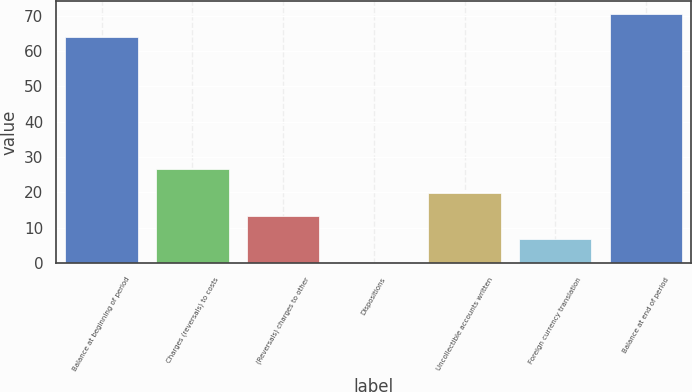Convert chart to OTSL. <chart><loc_0><loc_0><loc_500><loc_500><bar_chart><fcel>Balance at beginning of period<fcel>Charges (reversals) to costs<fcel>(Reversals) charges to other<fcel>Dispositions<fcel>Uncollectible accounts written<fcel>Foreign currency translation<fcel>Balance at end of period<nl><fcel>63.9<fcel>26.52<fcel>13.36<fcel>0.2<fcel>19.94<fcel>6.78<fcel>70.48<nl></chart> 